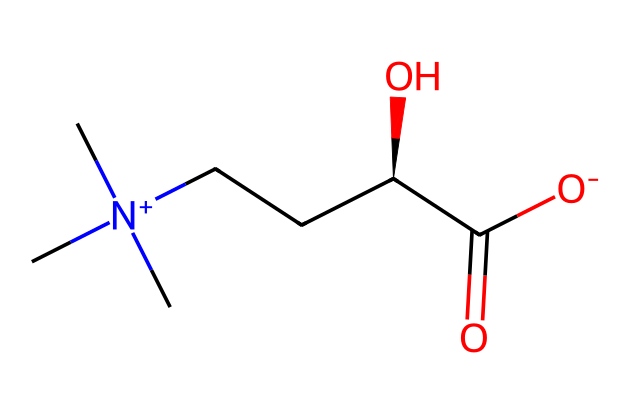What is the core functional group present in this ionic liquid? The molecule contains a carboxylate group, indicated by the presence of the carbonyl (C=O) and hydroxyl (O-) groups, which forms the distinguishing characteristic of a carboxylic acid derivative.
Answer: carboxylate How many carbon atoms are present in this ionic liquid? Count the carbon atoms in the SMILES representation: there are five carbon atoms connected in various ways, including in the alkyl chain and the carboxylate group.
Answer: five What type of charge does the nitrogen atom carry in this structure? The nitrogen atom has a positive charge indicated by "[N+]" in the SMILES, which is typical in ionic liquids where the nitrogen is quaternized.
Answer: positive What is the molecular formula derived from the SMILES representation? Analyzing the SMILES representation, we can deduce the counts of each element: carbon (C), hydrogen (H), nitrogen (N), and oxygen (O) to find the total number of each atom present, yielding a formula of C8H16N1O2.
Answer: C8H16N1O2 Does this ionic liquid have a hydrophilic or hydrophobic character? The presence of the carboxylate group and the positively charged nitrogen suggest the ionic liquid is hydrophilic due to these polar functionalities, which are conducive to interaction with water.
Answer: hydrophilic 